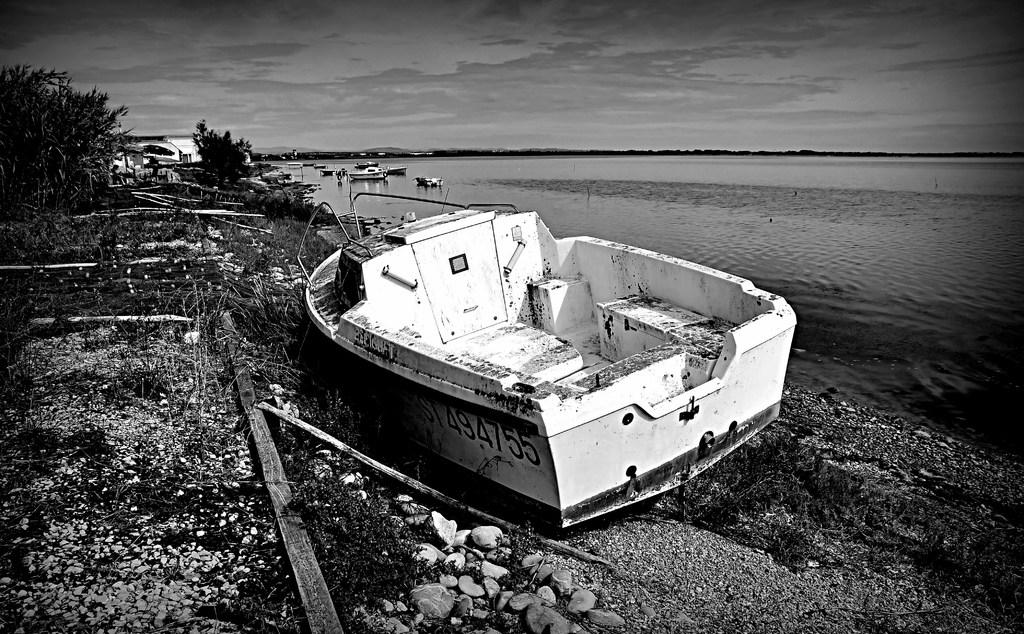What type of natural body is depicted in the image? There is a sea in the image. What activities are taking place in the sea? There are watercrafts sailing in the sea. Is there any watercraft located near the shore? Yes, a watercraft is placed at the seashore. What type of vegetation can be seen in the image? There are plants in the image. Where is the doll located in the image? There is no doll present in the image. What type of cemetery can be seen in the image? There is no cemetery present in the image; it features a sea with watercrafts and plants. 